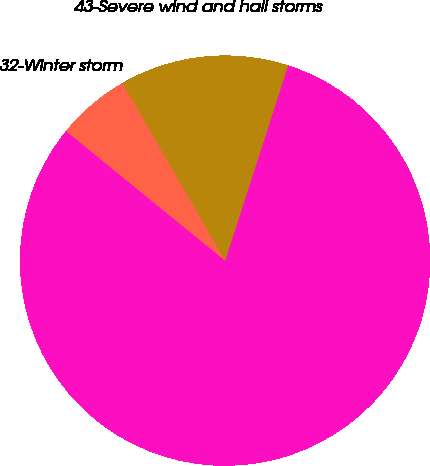Convert chart. <chart><loc_0><loc_0><loc_500><loc_500><pie_chart><fcel>(in millions pre-tax and net<fcel>32-Winter storm<fcel>43-Severe wind and hail storms<nl><fcel>80.92%<fcel>5.79%<fcel>13.3%<nl></chart> 